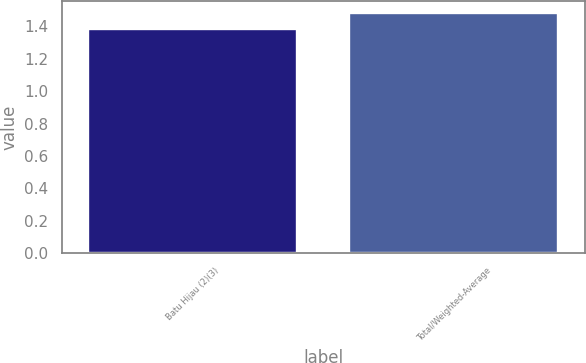Convert chart to OTSL. <chart><loc_0><loc_0><loc_500><loc_500><bar_chart><fcel>Batu Hijau (2)(3)<fcel>Total/Weighted-Average<nl><fcel>1.38<fcel>1.48<nl></chart> 